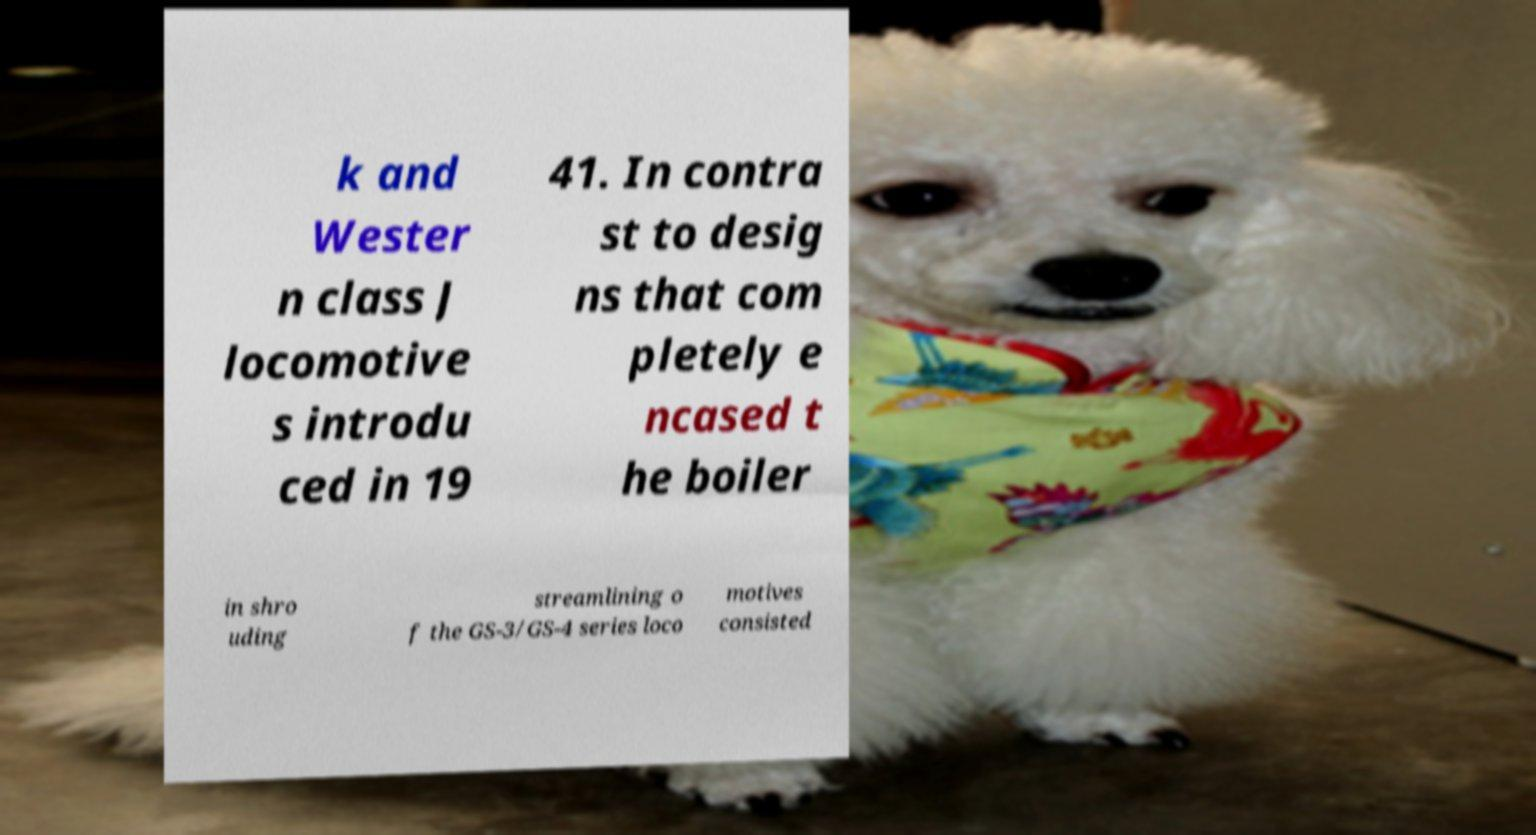Please read and relay the text visible in this image. What does it say? k and Wester n class J locomotive s introdu ced in 19 41. In contra st to desig ns that com pletely e ncased t he boiler in shro uding streamlining o f the GS-3/GS-4 series loco motives consisted 